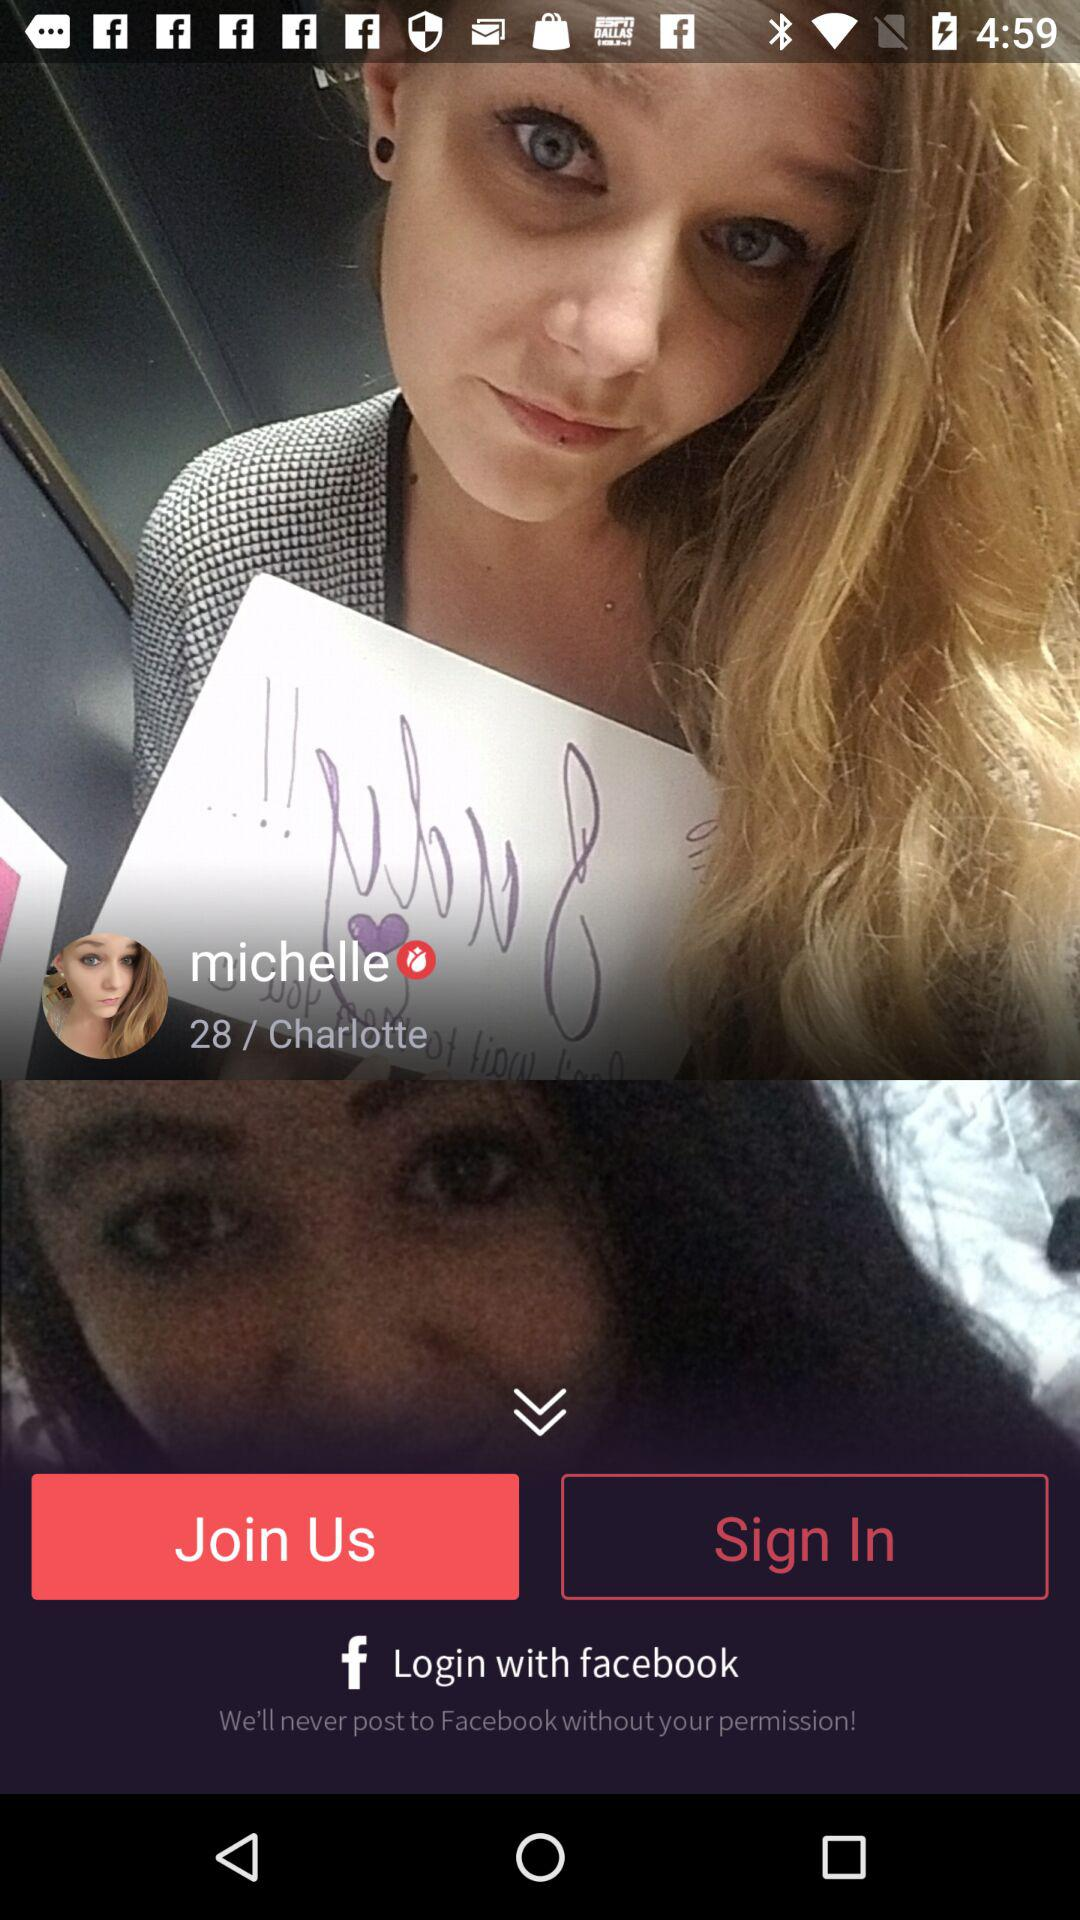Through what account log in can be done? Log in can be done through "facebook". 